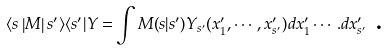Convert formula to latex. <formula><loc_0><loc_0><loc_500><loc_500>\langle s \left | { M } \right | s ^ { \prime } \rangle \langle s ^ { \prime } | { Y = } \int M { ( } s { | } s ^ { \prime } ) Y _ { s ^ { \prime } } ( x _ { 1 } ^ { \prime } , \cdots , x _ { s ^ { \prime } } ^ { \prime } ) d x _ { 1 } ^ { \prime } \cdots . d x _ { s ^ { \prime } } ^ { \prime } \text { .}</formula> 